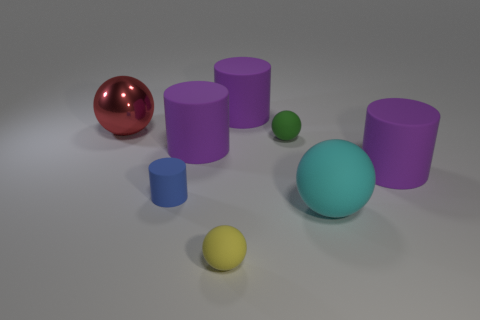There is a big purple cylinder that is behind the metal sphere; how many large purple rubber cylinders are to the left of it?
Provide a short and direct response. 1. How many blue cylinders have the same material as the big cyan sphere?
Make the answer very short. 1. There is a big red sphere; are there any small matte objects behind it?
Make the answer very short. No. There is another sphere that is the same size as the green rubber ball; what color is it?
Your response must be concise. Yellow. How many objects are either rubber objects behind the yellow thing or blue matte blocks?
Your answer should be very brief. 6. How big is the purple rubber object that is both to the right of the small yellow matte ball and on the left side of the big matte sphere?
Give a very brief answer. Large. How many other things are the same size as the cyan sphere?
Ensure brevity in your answer.  4. There is a big ball to the right of the purple object that is behind the ball to the left of the tiny blue thing; what is its color?
Your answer should be compact. Cyan. There is a tiny rubber thing that is both to the left of the small green ball and behind the cyan rubber ball; what shape is it?
Offer a terse response. Cylinder. What number of other things are there of the same shape as the blue matte thing?
Make the answer very short. 3. 